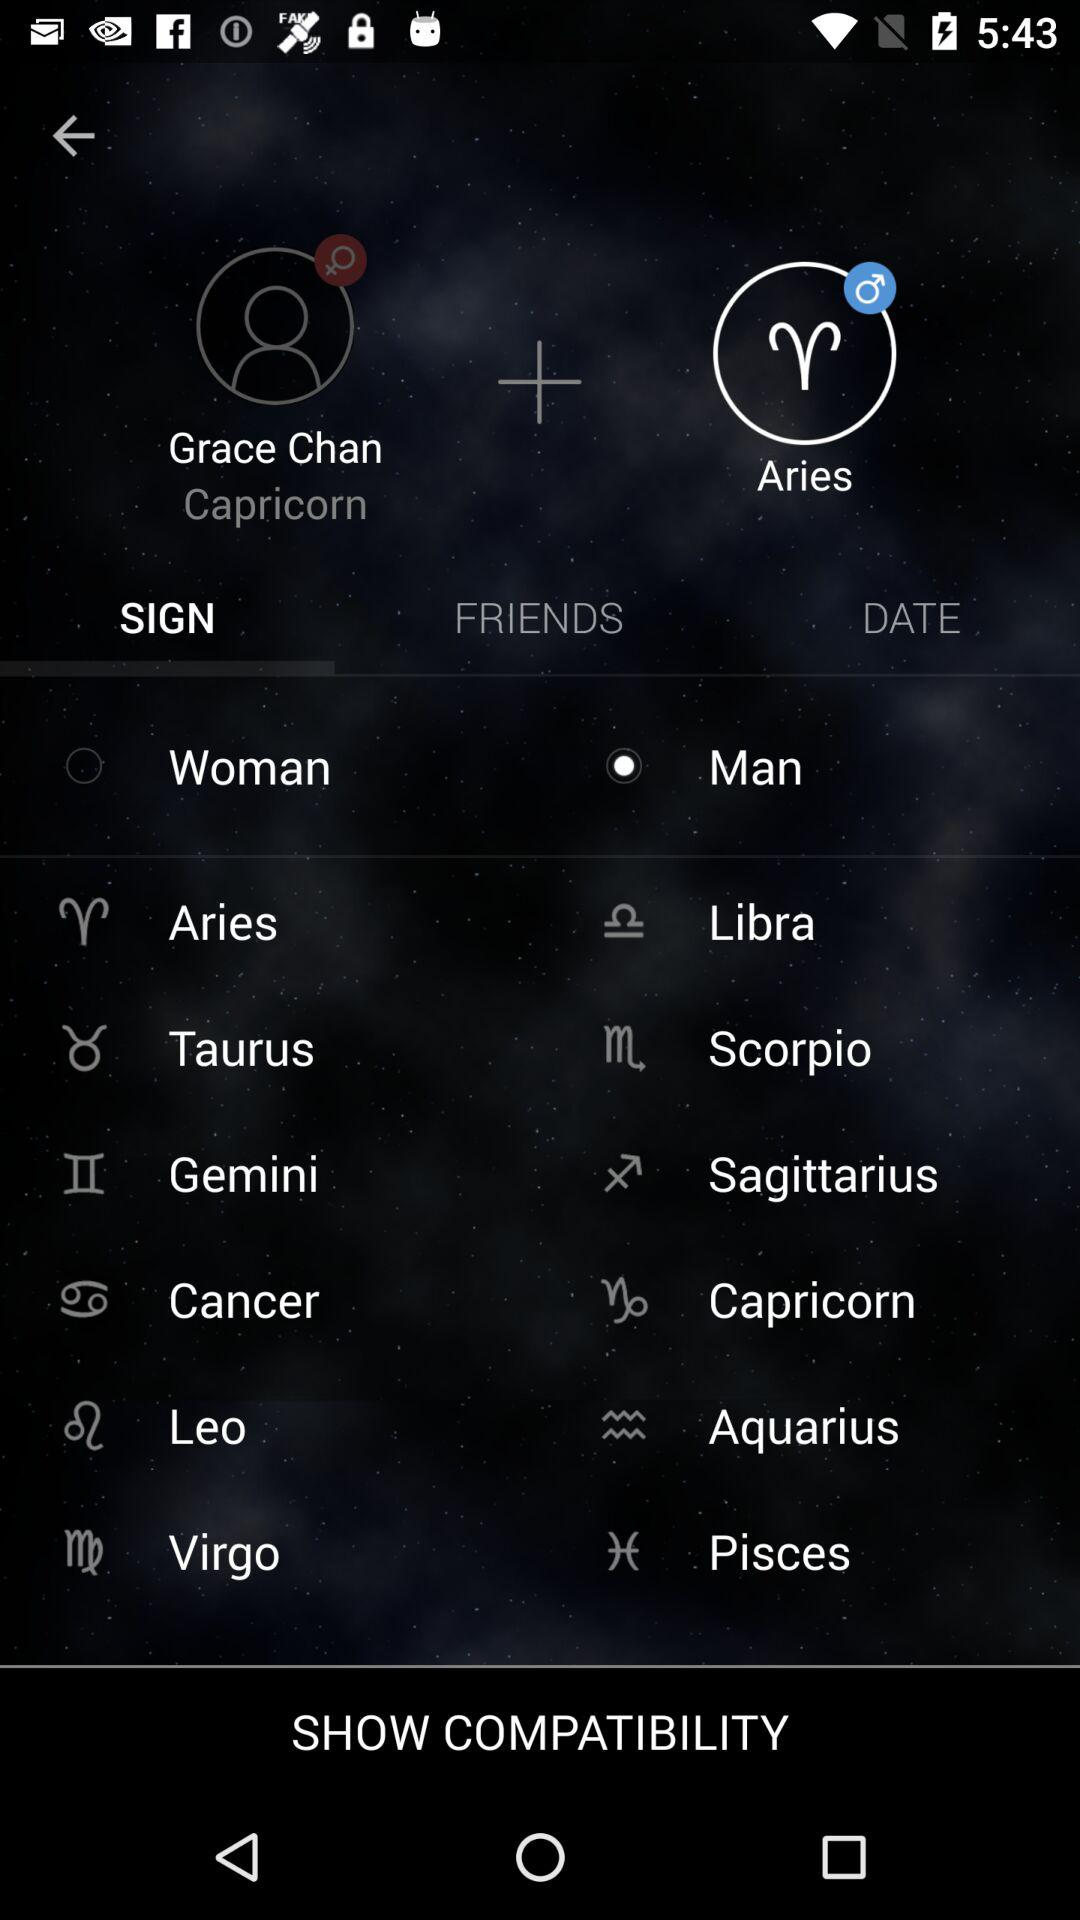What is the user name? The user name is Grace Chan. 